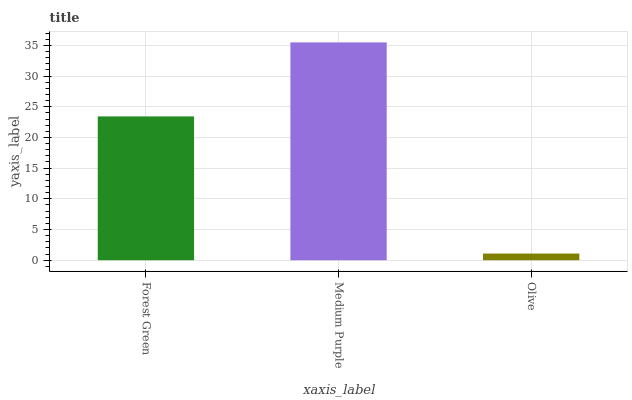Is Olive the minimum?
Answer yes or no. Yes. Is Medium Purple the maximum?
Answer yes or no. Yes. Is Medium Purple the minimum?
Answer yes or no. No. Is Olive the maximum?
Answer yes or no. No. Is Medium Purple greater than Olive?
Answer yes or no. Yes. Is Olive less than Medium Purple?
Answer yes or no. Yes. Is Olive greater than Medium Purple?
Answer yes or no. No. Is Medium Purple less than Olive?
Answer yes or no. No. Is Forest Green the high median?
Answer yes or no. Yes. Is Forest Green the low median?
Answer yes or no. Yes. Is Olive the high median?
Answer yes or no. No. Is Medium Purple the low median?
Answer yes or no. No. 